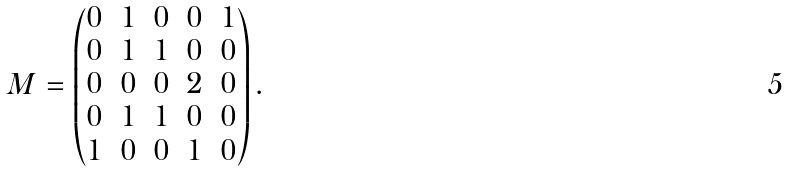Convert formula to latex. <formula><loc_0><loc_0><loc_500><loc_500>M = \begin{pmatrix} 0 & 1 & 0 & 0 & 1 \\ 0 & 1 & 1 & 0 & 0 \\ 0 & 0 & 0 & 2 & 0 \\ 0 & 1 & 1 & 0 & 0 \\ 1 & 0 & 0 & 1 & 0 \\ \end{pmatrix} .</formula> 